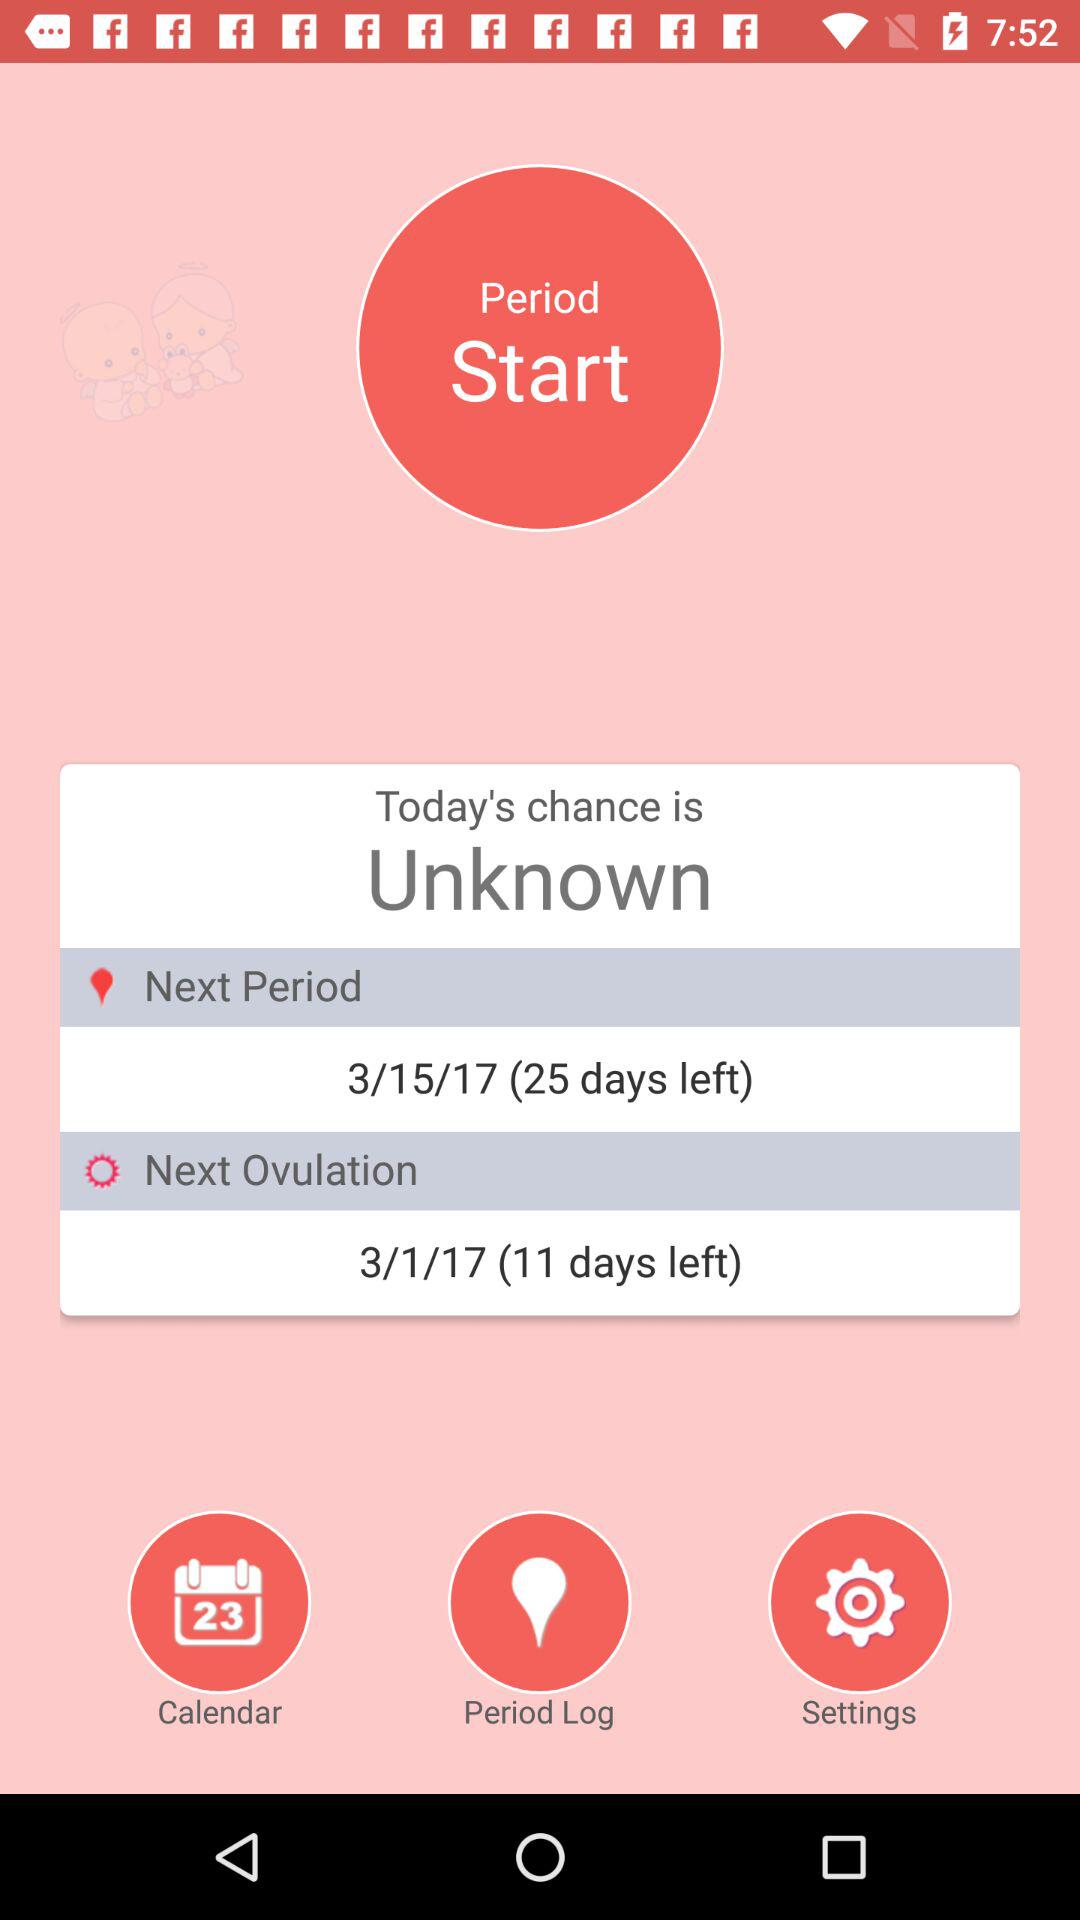What is the status of today's chance? The status is "Unknown". 